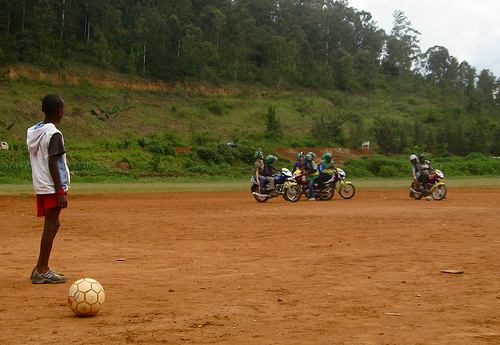<image>
Is there a bike behind the grass? No. The bike is not behind the grass. From this viewpoint, the bike appears to be positioned elsewhere in the scene. 